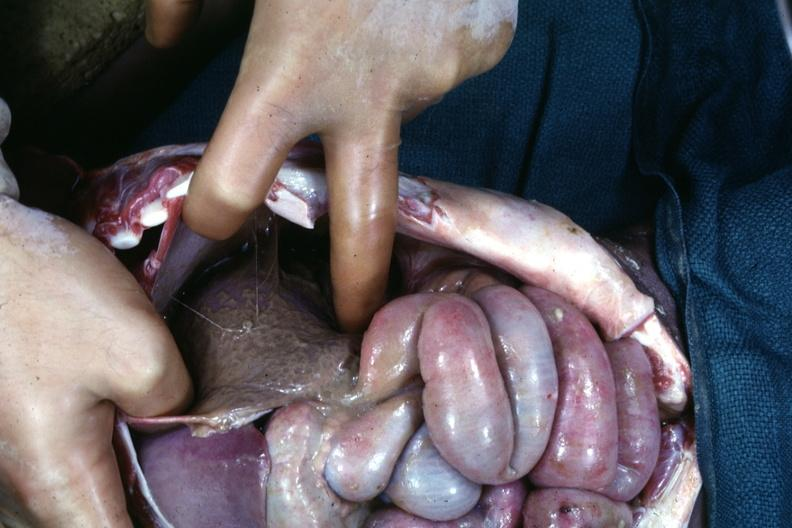where is this area in the body?
Answer the question using a single word or phrase. Abdomen 